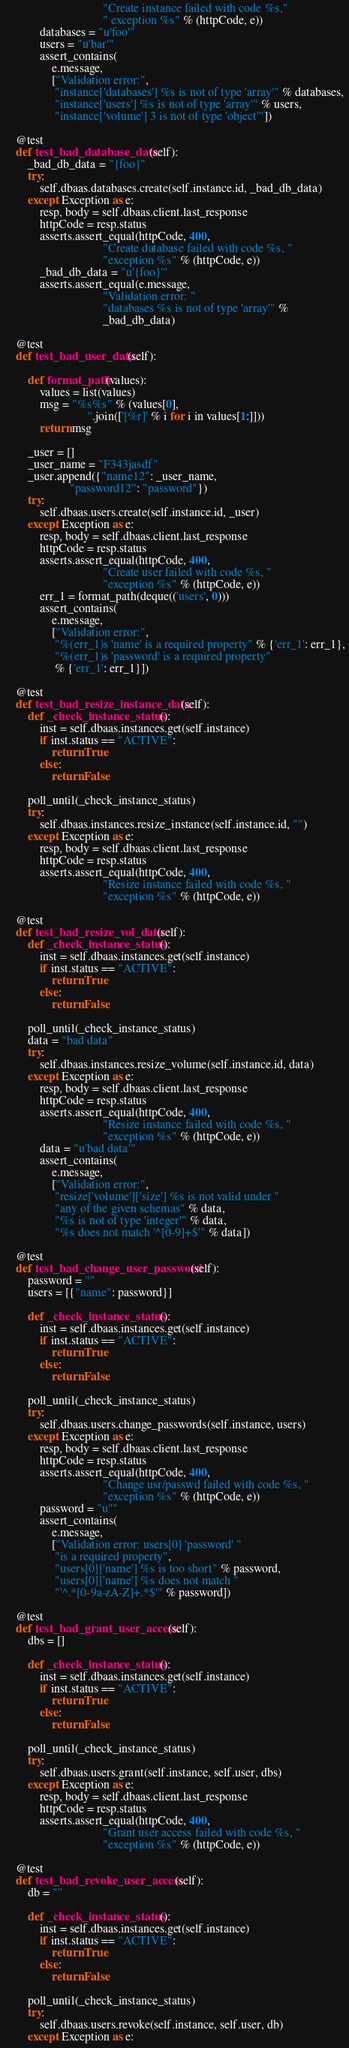<code> <loc_0><loc_0><loc_500><loc_500><_Python_>                                 "Create instance failed with code %s,"
                                 " exception %s" % (httpCode, e))
            databases = "u'foo'"
            users = "u'bar'"
            assert_contains(
                e.message,
                ["Validation error:",
                 "instance['databases'] %s is not of type 'array'" % databases,
                 "instance['users'] %s is not of type 'array'" % users,
                 "instance['volume'] 3 is not of type 'object'"])

    @test
    def test_bad_database_data(self):
        _bad_db_data = "{foo}"
        try:
            self.dbaas.databases.create(self.instance.id, _bad_db_data)
        except Exception as e:
            resp, body = self.dbaas.client.last_response
            httpCode = resp.status
            asserts.assert_equal(httpCode, 400,
                                 "Create database failed with code %s, "
                                 "exception %s" % (httpCode, e))
            _bad_db_data = "u'{foo}'"
            asserts.assert_equal(e.message,
                                 "Validation error: "
                                 "databases %s is not of type 'array'" %
                                 _bad_db_data)

    @test
    def test_bad_user_data(self):

        def format_path(values):
            values = list(values)
            msg = "%s%s" % (values[0],
                            ''.join(['[%r]' % i for i in values[1:]]))
            return msg

        _user = []
        _user_name = "F343jasdf"
        _user.append({"name12": _user_name,
                      "password12": "password"})
        try:
            self.dbaas.users.create(self.instance.id, _user)
        except Exception as e:
            resp, body = self.dbaas.client.last_response
            httpCode = resp.status
            asserts.assert_equal(httpCode, 400,
                                 "Create user failed with code %s, "
                                 "exception %s" % (httpCode, e))
            err_1 = format_path(deque(('users', 0)))
            assert_contains(
                e.message,
                ["Validation error:",
                 "%(err_1)s 'name' is a required property" % {'err_1': err_1},
                 "%(err_1)s 'password' is a required property"
                 % {'err_1': err_1}])

    @test
    def test_bad_resize_instance_data(self):
        def _check_instance_status():
            inst = self.dbaas.instances.get(self.instance)
            if inst.status == "ACTIVE":
                return True
            else:
                return False

        poll_until(_check_instance_status)
        try:
            self.dbaas.instances.resize_instance(self.instance.id, "")
        except Exception as e:
            resp, body = self.dbaas.client.last_response
            httpCode = resp.status
            asserts.assert_equal(httpCode, 400,
                                 "Resize instance failed with code %s, "
                                 "exception %s" % (httpCode, e))

    @test
    def test_bad_resize_vol_data(self):
        def _check_instance_status():
            inst = self.dbaas.instances.get(self.instance)
            if inst.status == "ACTIVE":
                return True
            else:
                return False

        poll_until(_check_instance_status)
        data = "bad data"
        try:
            self.dbaas.instances.resize_volume(self.instance.id, data)
        except Exception as e:
            resp, body = self.dbaas.client.last_response
            httpCode = resp.status
            asserts.assert_equal(httpCode, 400,
                                 "Resize instance failed with code %s, "
                                 "exception %s" % (httpCode, e))
            data = "u'bad data'"
            assert_contains(
                e.message,
                ["Validation error:",
                 "resize['volume']['size'] %s is not valid under "
                 "any of the given schemas" % data,
                 "%s is not of type 'integer'" % data,
                 "%s does not match '^[0-9]+$'" % data])

    @test
    def test_bad_change_user_password(self):
        password = ""
        users = [{"name": password}]

        def _check_instance_status():
            inst = self.dbaas.instances.get(self.instance)
            if inst.status == "ACTIVE":
                return True
            else:
                return False

        poll_until(_check_instance_status)
        try:
            self.dbaas.users.change_passwords(self.instance, users)
        except Exception as e:
            resp, body = self.dbaas.client.last_response
            httpCode = resp.status
            asserts.assert_equal(httpCode, 400,
                                 "Change usr/passwd failed with code %s, "
                                 "exception %s" % (httpCode, e))
            password = "u''"
            assert_contains(
                e.message,
                ["Validation error: users[0] 'password' "
                 "is a required property",
                 "users[0]['name'] %s is too short" % password,
                 "users[0]['name'] %s does not match "
                 "'^.*[0-9a-zA-Z]+.*$'" % password])

    @test
    def test_bad_grant_user_access(self):
        dbs = []

        def _check_instance_status():
            inst = self.dbaas.instances.get(self.instance)
            if inst.status == "ACTIVE":
                return True
            else:
                return False

        poll_until(_check_instance_status)
        try:
            self.dbaas.users.grant(self.instance, self.user, dbs)
        except Exception as e:
            resp, body = self.dbaas.client.last_response
            httpCode = resp.status
            asserts.assert_equal(httpCode, 400,
                                 "Grant user access failed with code %s, "
                                 "exception %s" % (httpCode, e))

    @test
    def test_bad_revoke_user_access(self):
        db = ""

        def _check_instance_status():
            inst = self.dbaas.instances.get(self.instance)
            if inst.status == "ACTIVE":
                return True
            else:
                return False

        poll_until(_check_instance_status)
        try:
            self.dbaas.users.revoke(self.instance, self.user, db)
        except Exception as e:</code> 